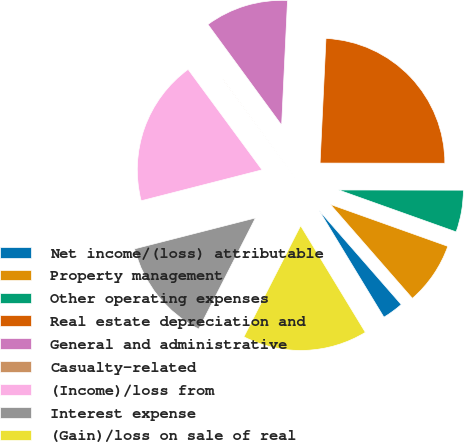Convert chart to OTSL. <chart><loc_0><loc_0><loc_500><loc_500><pie_chart><fcel>Net income/(loss) attributable<fcel>Property management<fcel>Other operating expenses<fcel>Real estate depreciation and<fcel>General and administrative<fcel>Casualty-related<fcel>(Income)/loss from<fcel>Interest expense<fcel>(Gain)/loss on sale of real<nl><fcel>2.74%<fcel>8.12%<fcel>5.43%<fcel>24.27%<fcel>10.81%<fcel>0.04%<fcel>18.89%<fcel>13.5%<fcel>16.2%<nl></chart> 